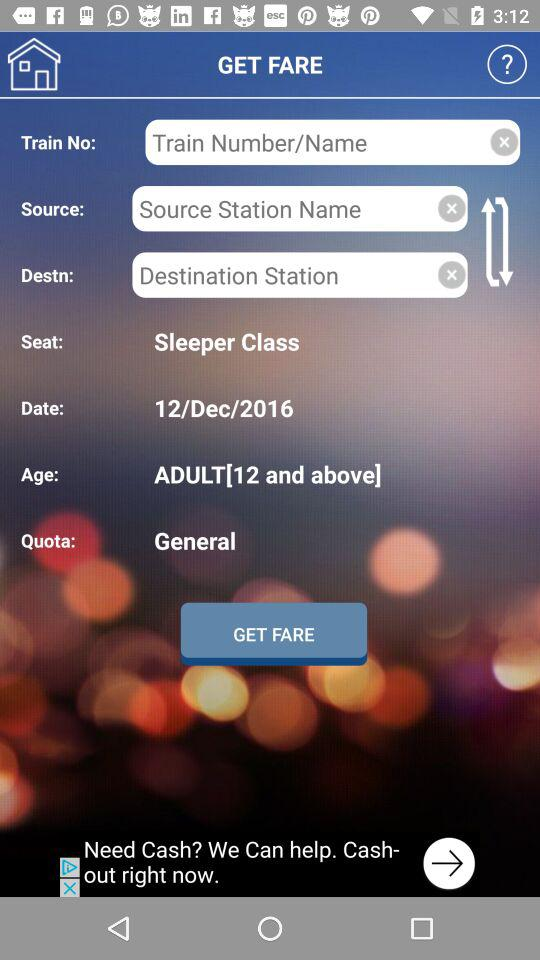What is the mentioned date? The mentioned date is December 12, 2016. 